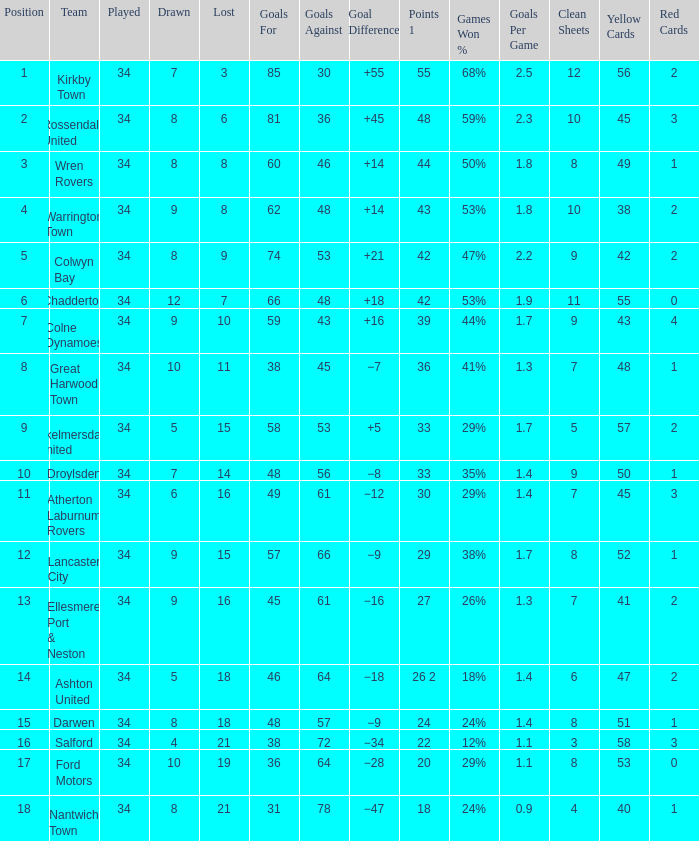What is the smallest number of goals against when 8 games were lost, and the goals for are 60? 46.0. 